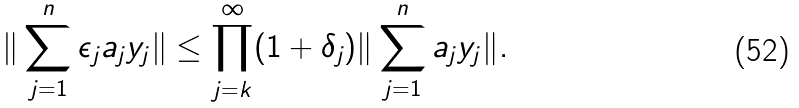<formula> <loc_0><loc_0><loc_500><loc_500>\| \sum _ { j = 1 } ^ { n } \epsilon _ { j } a _ { j } y _ { j } \| \leq \prod _ { j = k } ^ { \infty } ( 1 + \delta _ { j } ) \| \sum _ { j = 1 } ^ { n } a _ { j } y _ { j } \| .</formula> 